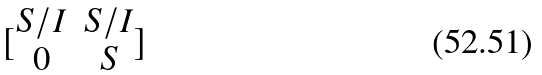Convert formula to latex. <formula><loc_0><loc_0><loc_500><loc_500>[ \begin{matrix} S / I & S / I \\ 0 & S \end{matrix} ]</formula> 